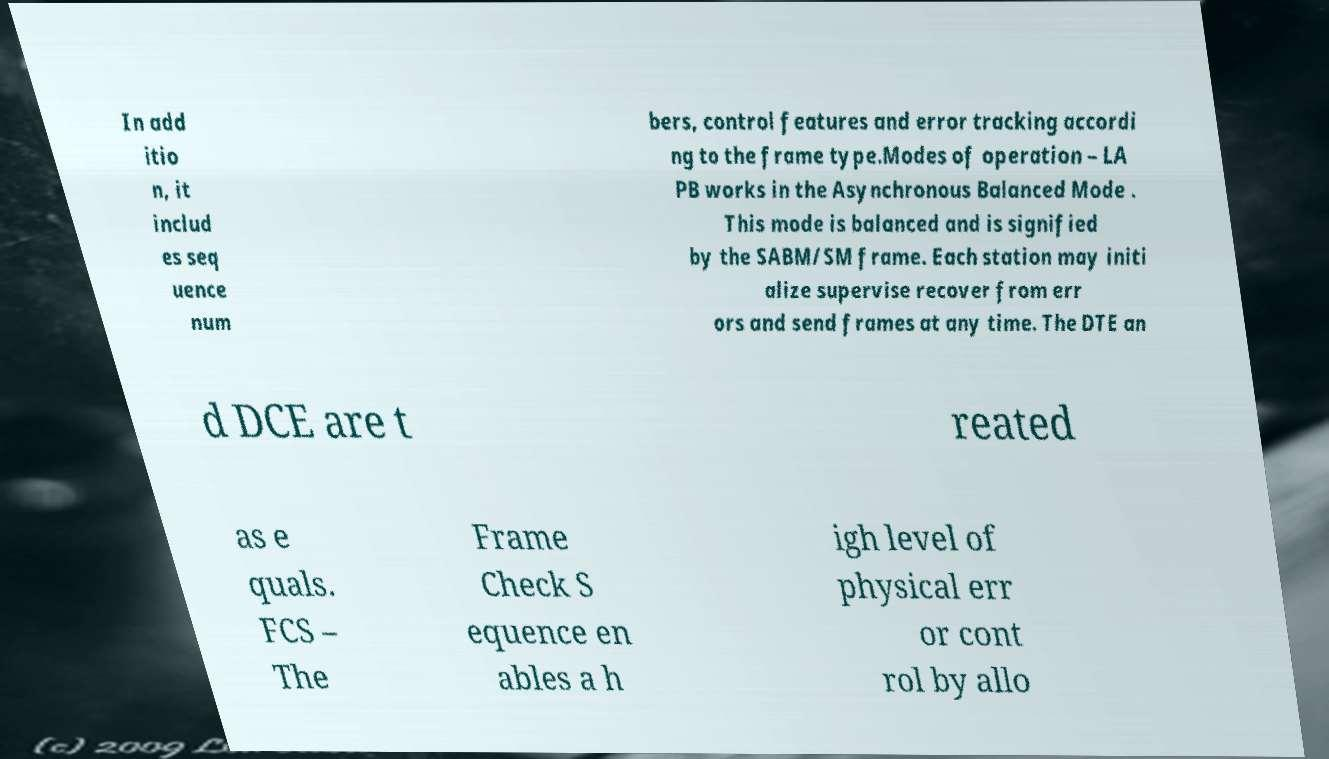Could you assist in decoding the text presented in this image and type it out clearly? In add itio n, it includ es seq uence num bers, control features and error tracking accordi ng to the frame type.Modes of operation – LA PB works in the Asynchronous Balanced Mode . This mode is balanced and is signified by the SABM/SM frame. Each station may initi alize supervise recover from err ors and send frames at any time. The DTE an d DCE are t reated as e quals. FCS – The Frame Check S equence en ables a h igh level of physical err or cont rol by allo 